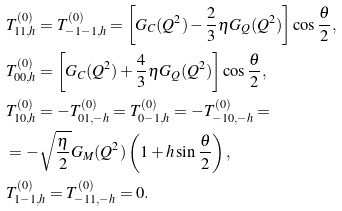<formula> <loc_0><loc_0><loc_500><loc_500>& T ^ { ( 0 ) } _ { 1 1 , h } = T ^ { ( 0 ) } _ { - 1 - 1 , h } = \left [ G _ { C } ( Q ^ { 2 } ) - \frac { 2 } { 3 } \eta G _ { Q } ( Q ^ { 2 } ) \right ] \cos \frac { \theta } { 2 } , \\ & T ^ { ( 0 ) } _ { 0 0 , h } = \left [ G _ { C } ( Q ^ { 2 } ) + \frac { 4 } { 3 } \eta G _ { Q } ( Q ^ { 2 } ) \right ] \cos \frac { \theta } { 2 } , \\ & T ^ { ( 0 ) } _ { 1 0 , h } = - T ^ { ( 0 ) } _ { 0 1 , - h } = T ^ { ( 0 ) } _ { 0 - 1 , h } = - T ^ { ( 0 ) } _ { - 1 0 , - h } = \\ & = - \sqrt { \frac { \eta } 2 } G _ { M } ( Q ^ { 2 } ) \left ( 1 + h \sin \frac { \theta } { 2 } \right ) , \\ & T ^ { ( 0 ) } _ { 1 - 1 , h } = T ^ { ( 0 ) } _ { - 1 1 , - h } = 0 .</formula> 